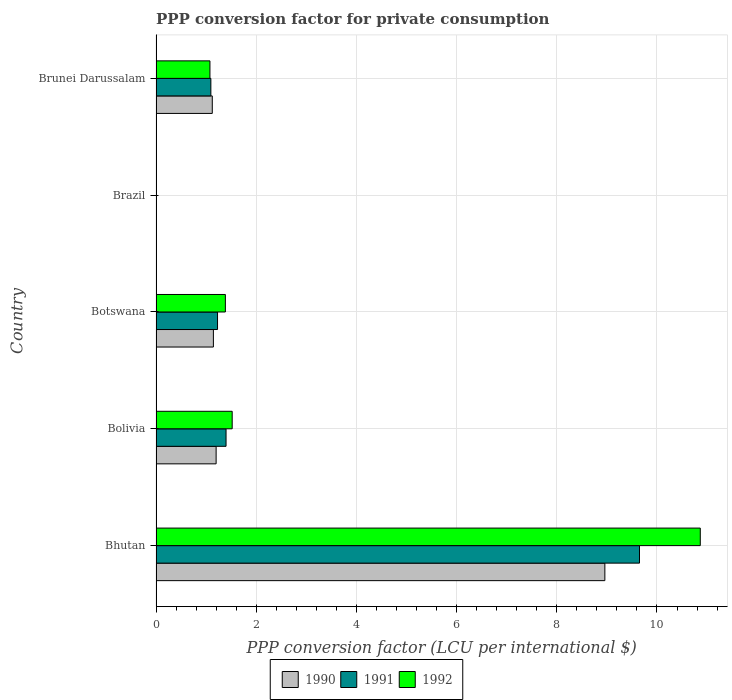How many different coloured bars are there?
Give a very brief answer. 3. Are the number of bars per tick equal to the number of legend labels?
Offer a very short reply. Yes. How many bars are there on the 2nd tick from the bottom?
Ensure brevity in your answer.  3. What is the label of the 5th group of bars from the top?
Ensure brevity in your answer.  Bhutan. What is the PPP conversion factor for private consumption in 1991 in Botswana?
Offer a terse response. 1.23. Across all countries, what is the maximum PPP conversion factor for private consumption in 1990?
Keep it short and to the point. 8.96. Across all countries, what is the minimum PPP conversion factor for private consumption in 1991?
Your response must be concise. 0. In which country was the PPP conversion factor for private consumption in 1990 maximum?
Give a very brief answer. Bhutan. In which country was the PPP conversion factor for private consumption in 1992 minimum?
Ensure brevity in your answer.  Brazil. What is the total PPP conversion factor for private consumption in 1991 in the graph?
Provide a succinct answer. 13.37. What is the difference between the PPP conversion factor for private consumption in 1990 in Brazil and that in Brunei Darussalam?
Provide a succinct answer. -1.12. What is the difference between the PPP conversion factor for private consumption in 1990 in Brunei Darussalam and the PPP conversion factor for private consumption in 1991 in Botswana?
Make the answer very short. -0.1. What is the average PPP conversion factor for private consumption in 1991 per country?
Give a very brief answer. 2.67. What is the difference between the PPP conversion factor for private consumption in 1991 and PPP conversion factor for private consumption in 1990 in Brunei Darussalam?
Give a very brief answer. -0.03. In how many countries, is the PPP conversion factor for private consumption in 1991 greater than 8.8 LCU?
Your response must be concise. 1. What is the ratio of the PPP conversion factor for private consumption in 1990 in Brazil to that in Brunei Darussalam?
Keep it short and to the point. 2.1289655063985313e-5. What is the difference between the highest and the second highest PPP conversion factor for private consumption in 1991?
Keep it short and to the point. 8.25. What is the difference between the highest and the lowest PPP conversion factor for private consumption in 1991?
Ensure brevity in your answer.  9.65. In how many countries, is the PPP conversion factor for private consumption in 1990 greater than the average PPP conversion factor for private consumption in 1990 taken over all countries?
Provide a short and direct response. 1. What does the 3rd bar from the top in Brunei Darussalam represents?
Your answer should be very brief. 1990. Is it the case that in every country, the sum of the PPP conversion factor for private consumption in 1991 and PPP conversion factor for private consumption in 1992 is greater than the PPP conversion factor for private consumption in 1990?
Provide a succinct answer. Yes. What is the difference between two consecutive major ticks on the X-axis?
Make the answer very short. 2. Does the graph contain grids?
Offer a terse response. Yes. What is the title of the graph?
Provide a short and direct response. PPP conversion factor for private consumption. What is the label or title of the X-axis?
Your answer should be very brief. PPP conversion factor (LCU per international $). What is the label or title of the Y-axis?
Your answer should be compact. Country. What is the PPP conversion factor (LCU per international $) of 1990 in Bhutan?
Provide a short and direct response. 8.96. What is the PPP conversion factor (LCU per international $) in 1991 in Bhutan?
Offer a terse response. 9.65. What is the PPP conversion factor (LCU per international $) of 1992 in Bhutan?
Your response must be concise. 10.86. What is the PPP conversion factor (LCU per international $) in 1990 in Bolivia?
Provide a short and direct response. 1.2. What is the PPP conversion factor (LCU per international $) in 1991 in Bolivia?
Give a very brief answer. 1.4. What is the PPP conversion factor (LCU per international $) in 1992 in Bolivia?
Your response must be concise. 1.52. What is the PPP conversion factor (LCU per international $) of 1990 in Botswana?
Keep it short and to the point. 1.15. What is the PPP conversion factor (LCU per international $) in 1991 in Botswana?
Keep it short and to the point. 1.23. What is the PPP conversion factor (LCU per international $) of 1992 in Botswana?
Give a very brief answer. 1.38. What is the PPP conversion factor (LCU per international $) in 1990 in Brazil?
Provide a succinct answer. 2.39117107766808e-5. What is the PPP conversion factor (LCU per international $) in 1991 in Brazil?
Provide a short and direct response. 0. What is the PPP conversion factor (LCU per international $) of 1992 in Brazil?
Your response must be concise. 0. What is the PPP conversion factor (LCU per international $) in 1990 in Brunei Darussalam?
Provide a succinct answer. 1.12. What is the PPP conversion factor (LCU per international $) in 1991 in Brunei Darussalam?
Offer a very short reply. 1.09. What is the PPP conversion factor (LCU per international $) of 1992 in Brunei Darussalam?
Give a very brief answer. 1.08. Across all countries, what is the maximum PPP conversion factor (LCU per international $) of 1990?
Provide a succinct answer. 8.96. Across all countries, what is the maximum PPP conversion factor (LCU per international $) of 1991?
Provide a short and direct response. 9.65. Across all countries, what is the maximum PPP conversion factor (LCU per international $) in 1992?
Your response must be concise. 10.86. Across all countries, what is the minimum PPP conversion factor (LCU per international $) of 1990?
Your answer should be very brief. 2.39117107766808e-5. Across all countries, what is the minimum PPP conversion factor (LCU per international $) of 1991?
Your answer should be very brief. 0. Across all countries, what is the minimum PPP conversion factor (LCU per international $) in 1992?
Provide a short and direct response. 0. What is the total PPP conversion factor (LCU per international $) of 1990 in the graph?
Give a very brief answer. 12.43. What is the total PPP conversion factor (LCU per international $) of 1991 in the graph?
Provide a short and direct response. 13.37. What is the total PPP conversion factor (LCU per international $) in 1992 in the graph?
Provide a short and direct response. 14.85. What is the difference between the PPP conversion factor (LCU per international $) in 1990 in Bhutan and that in Bolivia?
Provide a succinct answer. 7.76. What is the difference between the PPP conversion factor (LCU per international $) in 1991 in Bhutan and that in Bolivia?
Provide a succinct answer. 8.25. What is the difference between the PPP conversion factor (LCU per international $) of 1992 in Bhutan and that in Bolivia?
Your answer should be compact. 9.34. What is the difference between the PPP conversion factor (LCU per international $) of 1990 in Bhutan and that in Botswana?
Give a very brief answer. 7.81. What is the difference between the PPP conversion factor (LCU per international $) in 1991 in Bhutan and that in Botswana?
Make the answer very short. 8.42. What is the difference between the PPP conversion factor (LCU per international $) in 1992 in Bhutan and that in Botswana?
Provide a succinct answer. 9.48. What is the difference between the PPP conversion factor (LCU per international $) in 1990 in Bhutan and that in Brazil?
Make the answer very short. 8.96. What is the difference between the PPP conversion factor (LCU per international $) in 1991 in Bhutan and that in Brazil?
Offer a very short reply. 9.65. What is the difference between the PPP conversion factor (LCU per international $) of 1992 in Bhutan and that in Brazil?
Offer a very short reply. 10.86. What is the difference between the PPP conversion factor (LCU per international $) in 1990 in Bhutan and that in Brunei Darussalam?
Give a very brief answer. 7.84. What is the difference between the PPP conversion factor (LCU per international $) of 1991 in Bhutan and that in Brunei Darussalam?
Keep it short and to the point. 8.56. What is the difference between the PPP conversion factor (LCU per international $) in 1992 in Bhutan and that in Brunei Darussalam?
Make the answer very short. 9.79. What is the difference between the PPP conversion factor (LCU per international $) of 1990 in Bolivia and that in Botswana?
Give a very brief answer. 0.05. What is the difference between the PPP conversion factor (LCU per international $) in 1991 in Bolivia and that in Botswana?
Offer a terse response. 0.17. What is the difference between the PPP conversion factor (LCU per international $) in 1992 in Bolivia and that in Botswana?
Make the answer very short. 0.14. What is the difference between the PPP conversion factor (LCU per international $) of 1990 in Bolivia and that in Brazil?
Your answer should be compact. 1.2. What is the difference between the PPP conversion factor (LCU per international $) of 1991 in Bolivia and that in Brazil?
Your answer should be compact. 1.4. What is the difference between the PPP conversion factor (LCU per international $) in 1992 in Bolivia and that in Brazil?
Provide a short and direct response. 1.52. What is the difference between the PPP conversion factor (LCU per international $) of 1990 in Bolivia and that in Brunei Darussalam?
Ensure brevity in your answer.  0.08. What is the difference between the PPP conversion factor (LCU per international $) in 1991 in Bolivia and that in Brunei Darussalam?
Your answer should be compact. 0.3. What is the difference between the PPP conversion factor (LCU per international $) of 1992 in Bolivia and that in Brunei Darussalam?
Offer a very short reply. 0.44. What is the difference between the PPP conversion factor (LCU per international $) in 1990 in Botswana and that in Brazil?
Your answer should be very brief. 1.15. What is the difference between the PPP conversion factor (LCU per international $) of 1991 in Botswana and that in Brazil?
Your answer should be very brief. 1.23. What is the difference between the PPP conversion factor (LCU per international $) in 1992 in Botswana and that in Brazil?
Keep it short and to the point. 1.38. What is the difference between the PPP conversion factor (LCU per international $) in 1990 in Botswana and that in Brunei Darussalam?
Provide a succinct answer. 0.02. What is the difference between the PPP conversion factor (LCU per international $) in 1991 in Botswana and that in Brunei Darussalam?
Your response must be concise. 0.13. What is the difference between the PPP conversion factor (LCU per international $) of 1992 in Botswana and that in Brunei Darussalam?
Provide a short and direct response. 0.31. What is the difference between the PPP conversion factor (LCU per international $) of 1990 in Brazil and that in Brunei Darussalam?
Ensure brevity in your answer.  -1.12. What is the difference between the PPP conversion factor (LCU per international $) in 1991 in Brazil and that in Brunei Darussalam?
Provide a succinct answer. -1.09. What is the difference between the PPP conversion factor (LCU per international $) of 1992 in Brazil and that in Brunei Darussalam?
Keep it short and to the point. -1.07. What is the difference between the PPP conversion factor (LCU per international $) in 1990 in Bhutan and the PPP conversion factor (LCU per international $) in 1991 in Bolivia?
Your answer should be very brief. 7.56. What is the difference between the PPP conversion factor (LCU per international $) in 1990 in Bhutan and the PPP conversion factor (LCU per international $) in 1992 in Bolivia?
Provide a succinct answer. 7.44. What is the difference between the PPP conversion factor (LCU per international $) of 1991 in Bhutan and the PPP conversion factor (LCU per international $) of 1992 in Bolivia?
Offer a terse response. 8.13. What is the difference between the PPP conversion factor (LCU per international $) in 1990 in Bhutan and the PPP conversion factor (LCU per international $) in 1991 in Botswana?
Your answer should be compact. 7.73. What is the difference between the PPP conversion factor (LCU per international $) of 1990 in Bhutan and the PPP conversion factor (LCU per international $) of 1992 in Botswana?
Keep it short and to the point. 7.58. What is the difference between the PPP conversion factor (LCU per international $) of 1991 in Bhutan and the PPP conversion factor (LCU per international $) of 1992 in Botswana?
Keep it short and to the point. 8.27. What is the difference between the PPP conversion factor (LCU per international $) in 1990 in Bhutan and the PPP conversion factor (LCU per international $) in 1991 in Brazil?
Provide a short and direct response. 8.96. What is the difference between the PPP conversion factor (LCU per international $) of 1990 in Bhutan and the PPP conversion factor (LCU per international $) of 1992 in Brazil?
Your answer should be very brief. 8.96. What is the difference between the PPP conversion factor (LCU per international $) of 1991 in Bhutan and the PPP conversion factor (LCU per international $) of 1992 in Brazil?
Ensure brevity in your answer.  9.65. What is the difference between the PPP conversion factor (LCU per international $) of 1990 in Bhutan and the PPP conversion factor (LCU per international $) of 1991 in Brunei Darussalam?
Your response must be concise. 7.87. What is the difference between the PPP conversion factor (LCU per international $) of 1990 in Bhutan and the PPP conversion factor (LCU per international $) of 1992 in Brunei Darussalam?
Your answer should be very brief. 7.88. What is the difference between the PPP conversion factor (LCU per international $) in 1991 in Bhutan and the PPP conversion factor (LCU per international $) in 1992 in Brunei Darussalam?
Provide a short and direct response. 8.58. What is the difference between the PPP conversion factor (LCU per international $) in 1990 in Bolivia and the PPP conversion factor (LCU per international $) in 1991 in Botswana?
Your answer should be very brief. -0.03. What is the difference between the PPP conversion factor (LCU per international $) of 1990 in Bolivia and the PPP conversion factor (LCU per international $) of 1992 in Botswana?
Offer a terse response. -0.18. What is the difference between the PPP conversion factor (LCU per international $) in 1991 in Bolivia and the PPP conversion factor (LCU per international $) in 1992 in Botswana?
Offer a terse response. 0.01. What is the difference between the PPP conversion factor (LCU per international $) of 1990 in Bolivia and the PPP conversion factor (LCU per international $) of 1991 in Brazil?
Give a very brief answer. 1.2. What is the difference between the PPP conversion factor (LCU per international $) of 1990 in Bolivia and the PPP conversion factor (LCU per international $) of 1992 in Brazil?
Give a very brief answer. 1.2. What is the difference between the PPP conversion factor (LCU per international $) of 1991 in Bolivia and the PPP conversion factor (LCU per international $) of 1992 in Brazil?
Provide a succinct answer. 1.4. What is the difference between the PPP conversion factor (LCU per international $) of 1990 in Bolivia and the PPP conversion factor (LCU per international $) of 1991 in Brunei Darussalam?
Your answer should be compact. 0.11. What is the difference between the PPP conversion factor (LCU per international $) of 1990 in Bolivia and the PPP conversion factor (LCU per international $) of 1992 in Brunei Darussalam?
Make the answer very short. 0.12. What is the difference between the PPP conversion factor (LCU per international $) of 1991 in Bolivia and the PPP conversion factor (LCU per international $) of 1992 in Brunei Darussalam?
Your response must be concise. 0.32. What is the difference between the PPP conversion factor (LCU per international $) in 1990 in Botswana and the PPP conversion factor (LCU per international $) in 1991 in Brazil?
Keep it short and to the point. 1.15. What is the difference between the PPP conversion factor (LCU per international $) in 1990 in Botswana and the PPP conversion factor (LCU per international $) in 1992 in Brazil?
Your answer should be very brief. 1.14. What is the difference between the PPP conversion factor (LCU per international $) of 1991 in Botswana and the PPP conversion factor (LCU per international $) of 1992 in Brazil?
Offer a terse response. 1.23. What is the difference between the PPP conversion factor (LCU per international $) in 1990 in Botswana and the PPP conversion factor (LCU per international $) in 1991 in Brunei Darussalam?
Keep it short and to the point. 0.05. What is the difference between the PPP conversion factor (LCU per international $) in 1990 in Botswana and the PPP conversion factor (LCU per international $) in 1992 in Brunei Darussalam?
Provide a short and direct response. 0.07. What is the difference between the PPP conversion factor (LCU per international $) in 1991 in Botswana and the PPP conversion factor (LCU per international $) in 1992 in Brunei Darussalam?
Your answer should be very brief. 0.15. What is the difference between the PPP conversion factor (LCU per international $) in 1990 in Brazil and the PPP conversion factor (LCU per international $) in 1991 in Brunei Darussalam?
Make the answer very short. -1.09. What is the difference between the PPP conversion factor (LCU per international $) of 1990 in Brazil and the PPP conversion factor (LCU per international $) of 1992 in Brunei Darussalam?
Offer a very short reply. -1.08. What is the difference between the PPP conversion factor (LCU per international $) of 1991 in Brazil and the PPP conversion factor (LCU per international $) of 1992 in Brunei Darussalam?
Keep it short and to the point. -1.08. What is the average PPP conversion factor (LCU per international $) of 1990 per country?
Your response must be concise. 2.49. What is the average PPP conversion factor (LCU per international $) of 1991 per country?
Your answer should be compact. 2.67. What is the average PPP conversion factor (LCU per international $) of 1992 per country?
Provide a short and direct response. 2.97. What is the difference between the PPP conversion factor (LCU per international $) of 1990 and PPP conversion factor (LCU per international $) of 1991 in Bhutan?
Offer a terse response. -0.69. What is the difference between the PPP conversion factor (LCU per international $) in 1990 and PPP conversion factor (LCU per international $) in 1992 in Bhutan?
Provide a short and direct response. -1.9. What is the difference between the PPP conversion factor (LCU per international $) of 1991 and PPP conversion factor (LCU per international $) of 1992 in Bhutan?
Keep it short and to the point. -1.21. What is the difference between the PPP conversion factor (LCU per international $) of 1990 and PPP conversion factor (LCU per international $) of 1991 in Bolivia?
Provide a succinct answer. -0.2. What is the difference between the PPP conversion factor (LCU per international $) in 1990 and PPP conversion factor (LCU per international $) in 1992 in Bolivia?
Your response must be concise. -0.32. What is the difference between the PPP conversion factor (LCU per international $) of 1991 and PPP conversion factor (LCU per international $) of 1992 in Bolivia?
Ensure brevity in your answer.  -0.12. What is the difference between the PPP conversion factor (LCU per international $) in 1990 and PPP conversion factor (LCU per international $) in 1991 in Botswana?
Your answer should be compact. -0.08. What is the difference between the PPP conversion factor (LCU per international $) of 1990 and PPP conversion factor (LCU per international $) of 1992 in Botswana?
Keep it short and to the point. -0.24. What is the difference between the PPP conversion factor (LCU per international $) in 1991 and PPP conversion factor (LCU per international $) in 1992 in Botswana?
Provide a succinct answer. -0.16. What is the difference between the PPP conversion factor (LCU per international $) in 1990 and PPP conversion factor (LCU per international $) in 1991 in Brazil?
Your answer should be very brief. -0. What is the difference between the PPP conversion factor (LCU per international $) of 1990 and PPP conversion factor (LCU per international $) of 1992 in Brazil?
Provide a succinct answer. -0. What is the difference between the PPP conversion factor (LCU per international $) of 1991 and PPP conversion factor (LCU per international $) of 1992 in Brazil?
Your answer should be very brief. -0. What is the difference between the PPP conversion factor (LCU per international $) in 1990 and PPP conversion factor (LCU per international $) in 1991 in Brunei Darussalam?
Make the answer very short. 0.03. What is the difference between the PPP conversion factor (LCU per international $) in 1990 and PPP conversion factor (LCU per international $) in 1992 in Brunei Darussalam?
Provide a short and direct response. 0.05. What is the difference between the PPP conversion factor (LCU per international $) in 1991 and PPP conversion factor (LCU per international $) in 1992 in Brunei Darussalam?
Keep it short and to the point. 0.02. What is the ratio of the PPP conversion factor (LCU per international $) in 1990 in Bhutan to that in Bolivia?
Give a very brief answer. 7.47. What is the ratio of the PPP conversion factor (LCU per international $) of 1991 in Bhutan to that in Bolivia?
Offer a terse response. 6.9. What is the ratio of the PPP conversion factor (LCU per international $) in 1992 in Bhutan to that in Bolivia?
Ensure brevity in your answer.  7.15. What is the ratio of the PPP conversion factor (LCU per international $) of 1990 in Bhutan to that in Botswana?
Keep it short and to the point. 7.82. What is the ratio of the PPP conversion factor (LCU per international $) in 1991 in Bhutan to that in Botswana?
Your answer should be compact. 7.86. What is the ratio of the PPP conversion factor (LCU per international $) in 1992 in Bhutan to that in Botswana?
Provide a succinct answer. 7.85. What is the ratio of the PPP conversion factor (LCU per international $) in 1990 in Bhutan to that in Brazil?
Ensure brevity in your answer.  3.75e+05. What is the ratio of the PPP conversion factor (LCU per international $) of 1991 in Bhutan to that in Brazil?
Provide a succinct answer. 7.90e+04. What is the ratio of the PPP conversion factor (LCU per international $) of 1992 in Bhutan to that in Brazil?
Keep it short and to the point. 8708.81. What is the ratio of the PPP conversion factor (LCU per international $) of 1990 in Bhutan to that in Brunei Darussalam?
Your answer should be very brief. 7.98. What is the ratio of the PPP conversion factor (LCU per international $) of 1991 in Bhutan to that in Brunei Darussalam?
Offer a very short reply. 8.82. What is the ratio of the PPP conversion factor (LCU per international $) of 1992 in Bhutan to that in Brunei Darussalam?
Ensure brevity in your answer.  10.1. What is the ratio of the PPP conversion factor (LCU per international $) of 1990 in Bolivia to that in Botswana?
Give a very brief answer. 1.05. What is the ratio of the PPP conversion factor (LCU per international $) of 1991 in Bolivia to that in Botswana?
Provide a short and direct response. 1.14. What is the ratio of the PPP conversion factor (LCU per international $) of 1992 in Bolivia to that in Botswana?
Keep it short and to the point. 1.1. What is the ratio of the PPP conversion factor (LCU per international $) in 1990 in Bolivia to that in Brazil?
Offer a very short reply. 5.02e+04. What is the ratio of the PPP conversion factor (LCU per international $) of 1991 in Bolivia to that in Brazil?
Provide a succinct answer. 1.14e+04. What is the ratio of the PPP conversion factor (LCU per international $) of 1992 in Bolivia to that in Brazil?
Your response must be concise. 1218.79. What is the ratio of the PPP conversion factor (LCU per international $) of 1990 in Bolivia to that in Brunei Darussalam?
Give a very brief answer. 1.07. What is the ratio of the PPP conversion factor (LCU per international $) in 1991 in Bolivia to that in Brunei Darussalam?
Your response must be concise. 1.28. What is the ratio of the PPP conversion factor (LCU per international $) in 1992 in Bolivia to that in Brunei Darussalam?
Your answer should be compact. 1.41. What is the ratio of the PPP conversion factor (LCU per international $) in 1990 in Botswana to that in Brazil?
Ensure brevity in your answer.  4.79e+04. What is the ratio of the PPP conversion factor (LCU per international $) in 1991 in Botswana to that in Brazil?
Offer a terse response. 1.00e+04. What is the ratio of the PPP conversion factor (LCU per international $) in 1992 in Botswana to that in Brazil?
Provide a short and direct response. 1109.75. What is the ratio of the PPP conversion factor (LCU per international $) of 1990 in Botswana to that in Brunei Darussalam?
Make the answer very short. 1.02. What is the ratio of the PPP conversion factor (LCU per international $) in 1991 in Botswana to that in Brunei Darussalam?
Your answer should be compact. 1.12. What is the ratio of the PPP conversion factor (LCU per international $) in 1992 in Botswana to that in Brunei Darussalam?
Your answer should be very brief. 1.29. What is the ratio of the PPP conversion factor (LCU per international $) of 1992 in Brazil to that in Brunei Darussalam?
Provide a succinct answer. 0. What is the difference between the highest and the second highest PPP conversion factor (LCU per international $) in 1990?
Offer a very short reply. 7.76. What is the difference between the highest and the second highest PPP conversion factor (LCU per international $) in 1991?
Offer a terse response. 8.25. What is the difference between the highest and the second highest PPP conversion factor (LCU per international $) of 1992?
Give a very brief answer. 9.34. What is the difference between the highest and the lowest PPP conversion factor (LCU per international $) of 1990?
Offer a terse response. 8.96. What is the difference between the highest and the lowest PPP conversion factor (LCU per international $) in 1991?
Your answer should be very brief. 9.65. What is the difference between the highest and the lowest PPP conversion factor (LCU per international $) in 1992?
Keep it short and to the point. 10.86. 